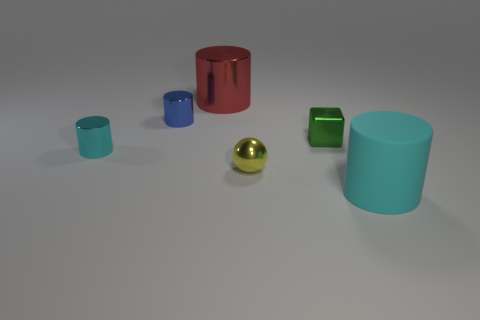What number of red objects are there?
Your answer should be compact. 1. Are there any rubber cylinders of the same size as the red metal thing?
Make the answer very short. Yes. Is the blue thing made of the same material as the thing that is to the right of the green metal object?
Your answer should be compact. No. What is the material of the big thing that is behind the small cyan shiny cylinder?
Provide a succinct answer. Metal. The yellow ball has what size?
Provide a succinct answer. Small. Does the cyan cylinder on the left side of the cyan rubber object have the same size as the cylinder on the right side of the red metallic object?
Provide a short and direct response. No. There is a red shiny thing that is the same shape as the tiny blue shiny thing; what is its size?
Offer a terse response. Large. There is a matte thing; is its size the same as the object that is on the left side of the blue cylinder?
Provide a succinct answer. No. There is a cyan thing behind the small ball; is there a yellow metal thing that is behind it?
Ensure brevity in your answer.  No. There is a cyan object to the left of the red cylinder; what is its shape?
Provide a succinct answer. Cylinder. 